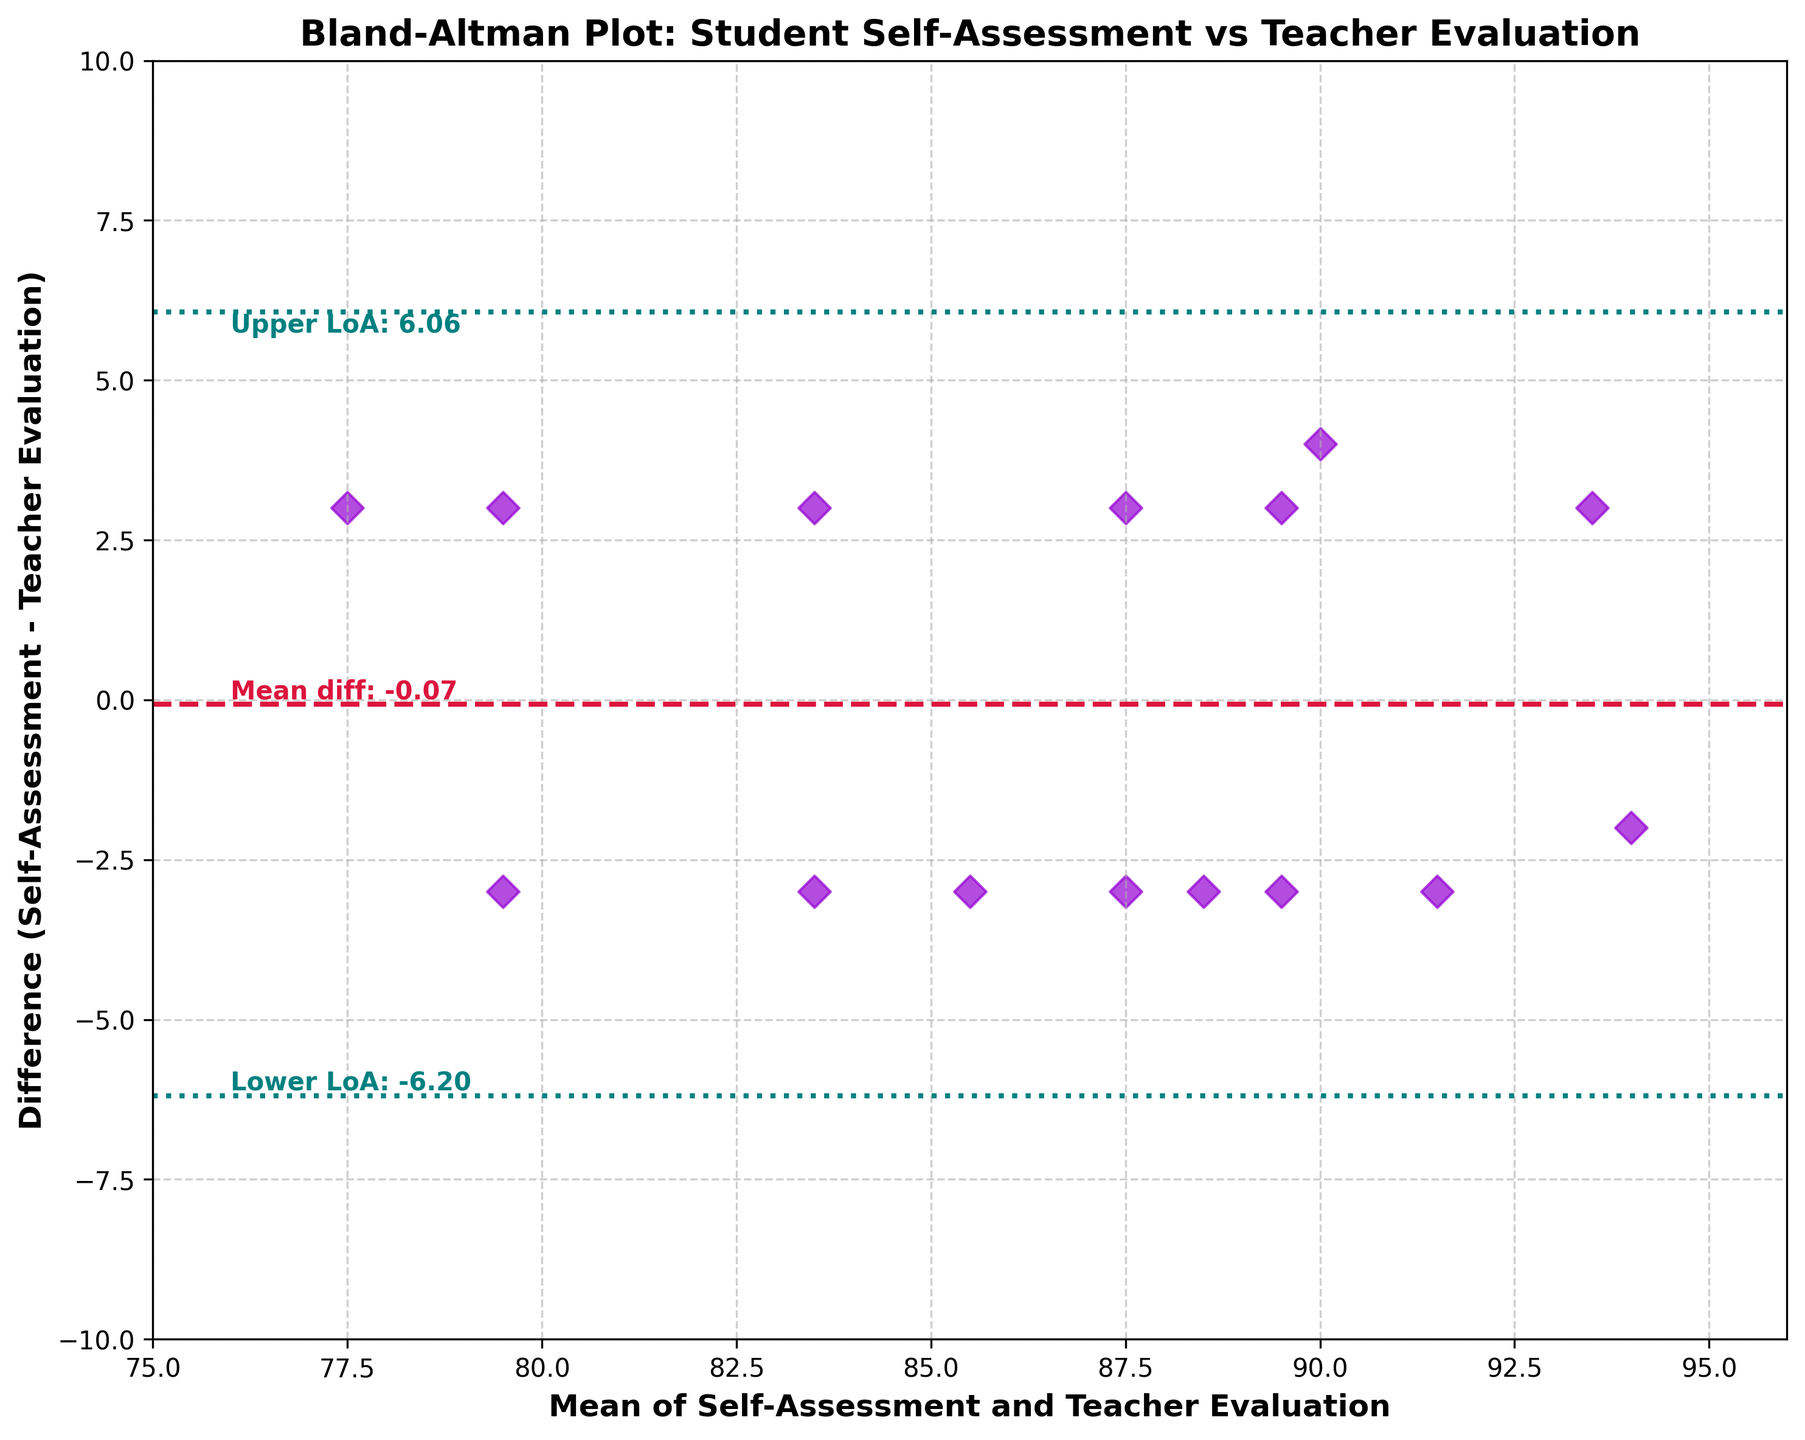How many data points are plotted? The plot shows points for each student in the dataset. The number of students listed corresponds to the number of data points.
Answer: 15 What's the title of the plot? The title is visible at the top of the plot.
Answer: Bland-Altman Plot: Student Self-Assessment vs Teacher Evaluation What is the average difference between self-assessment and teacher evaluation? The average difference is shown as the mean difference line on the plot.
Answer: -0.73 What is the lower limit of agreement? The lower limit of agreement is indicated by the lower horizontal dotted line on the plot.
Answer: -4.85 Which student's self-assessment had the largest positive difference from the teacher's evaluation? Analyzing the highest point above the mean difference line, we find the student with the largest positive difference.
Answer: Ethan Patel Which evaluation had the smallest negative difference, and what is its value? Identifying the closest point below the mean difference line reveals the smallest negative difference.
Answer: Michael Johnson, -3 What are the approximate limits for the x-axis and y-axis? The x-axis ranges from the lowest to the highest average, which spans wider than the range of means. Similarly, the y-axis covers the spectrum of differences.
Answer: x-axis: 75-96, y-axis: -10 to 10 What is the difference for the point where the average is 91.5? Find the plotted point where the average is 91.5, then check the corresponding difference value.
Answer: -3 (Isabella Nguyen) 